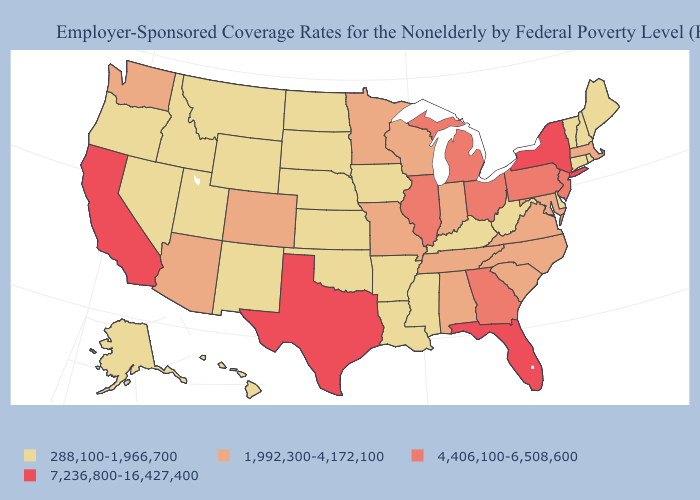What is the highest value in the MidWest ?
Quick response, please. 4,406,100-6,508,600. Does New Jersey have the lowest value in the USA?
Be succinct. No. Among the states that border Louisiana , does Arkansas have the lowest value?
Quick response, please. Yes. Is the legend a continuous bar?
Give a very brief answer. No. Does the first symbol in the legend represent the smallest category?
Keep it brief. Yes. Does the map have missing data?
Short answer required. No. What is the lowest value in states that border Arizona?
Be succinct. 288,100-1,966,700. Name the states that have a value in the range 288,100-1,966,700?
Concise answer only. Alaska, Arkansas, Connecticut, Delaware, Hawaii, Idaho, Iowa, Kansas, Kentucky, Louisiana, Maine, Mississippi, Montana, Nebraska, Nevada, New Hampshire, New Mexico, North Dakota, Oklahoma, Oregon, Rhode Island, South Dakota, Utah, Vermont, West Virginia, Wyoming. Name the states that have a value in the range 7,236,800-16,427,400?
Quick response, please. California, Florida, New York, Texas. Does Pennsylvania have a lower value than Texas?
Give a very brief answer. Yes. Which states have the lowest value in the USA?
Give a very brief answer. Alaska, Arkansas, Connecticut, Delaware, Hawaii, Idaho, Iowa, Kansas, Kentucky, Louisiana, Maine, Mississippi, Montana, Nebraska, Nevada, New Hampshire, New Mexico, North Dakota, Oklahoma, Oregon, Rhode Island, South Dakota, Utah, Vermont, West Virginia, Wyoming. What is the value of Idaho?
Answer briefly. 288,100-1,966,700. Name the states that have a value in the range 1,992,300-4,172,100?
Keep it brief. Alabama, Arizona, Colorado, Indiana, Maryland, Massachusetts, Minnesota, Missouri, North Carolina, South Carolina, Tennessee, Virginia, Washington, Wisconsin. Name the states that have a value in the range 7,236,800-16,427,400?
Quick response, please. California, Florida, New York, Texas. Name the states that have a value in the range 7,236,800-16,427,400?
Be succinct. California, Florida, New York, Texas. 